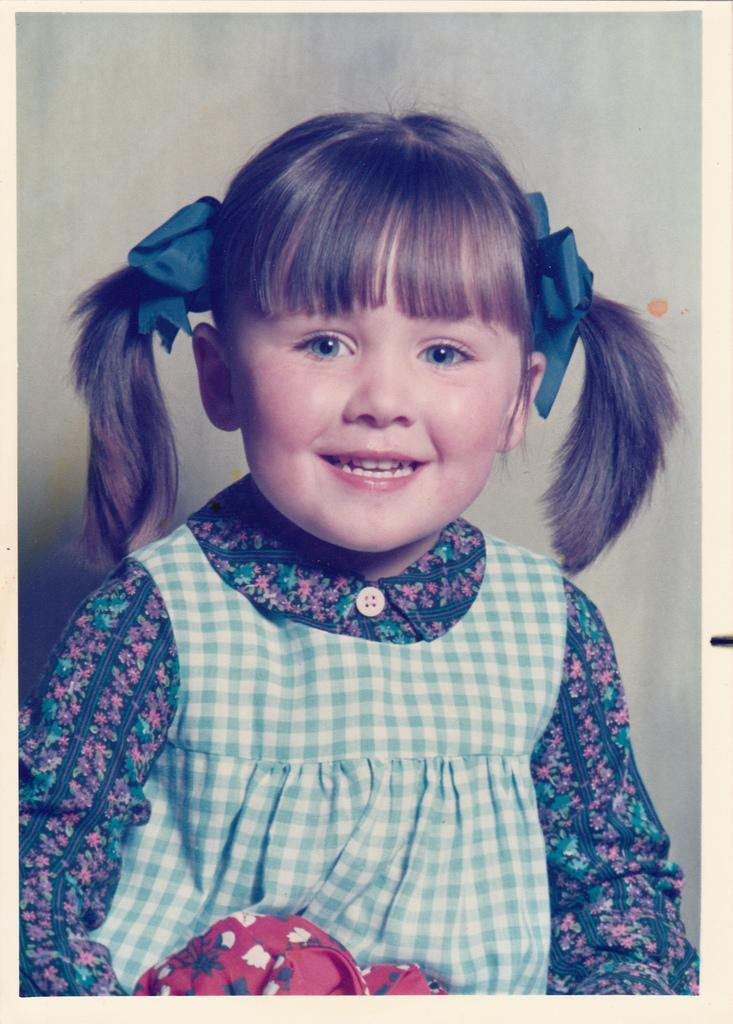Who is present in the image? There is a girl in the image. What is the girl's expression in the image? The girl is smiling in the image. What date is circled on the calendar in the image? There is no calendar present in the image, so it is not possible to answer that question. 